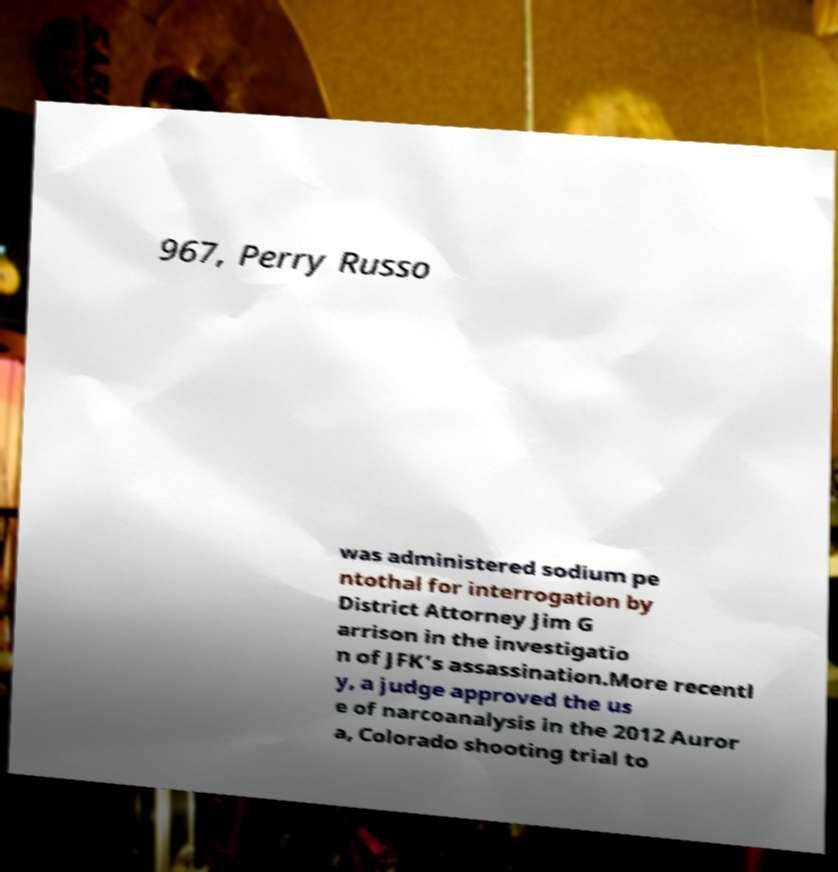What messages or text are displayed in this image? I need them in a readable, typed format. 967, Perry Russo was administered sodium pe ntothal for interrogation by District Attorney Jim G arrison in the investigatio n of JFK's assassination.More recentl y, a judge approved the us e of narcoanalysis in the 2012 Auror a, Colorado shooting trial to 